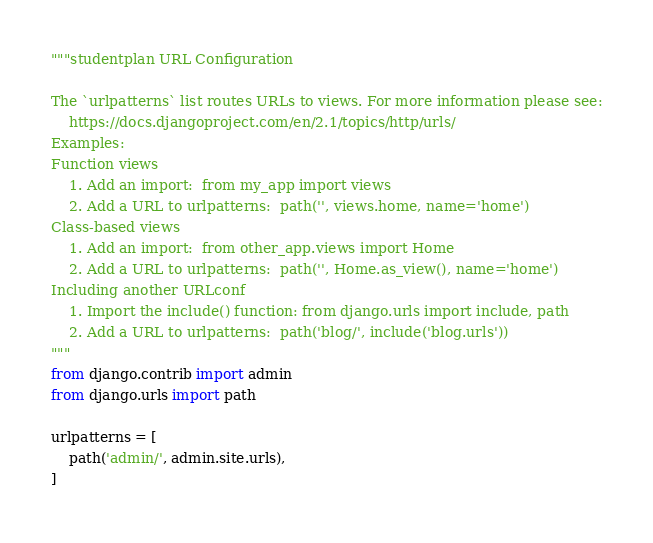<code> <loc_0><loc_0><loc_500><loc_500><_Python_>"""studentplan URL Configuration

The `urlpatterns` list routes URLs to views. For more information please see:
    https://docs.djangoproject.com/en/2.1/topics/http/urls/
Examples:
Function views
    1. Add an import:  from my_app import views
    2. Add a URL to urlpatterns:  path('', views.home, name='home')
Class-based views
    1. Add an import:  from other_app.views import Home
    2. Add a URL to urlpatterns:  path('', Home.as_view(), name='home')
Including another URLconf
    1. Import the include() function: from django.urls import include, path
    2. Add a URL to urlpatterns:  path('blog/', include('blog.urls'))
"""
from django.contrib import admin
from django.urls import path

urlpatterns = [
    path('admin/', admin.site.urls),
]
</code> 